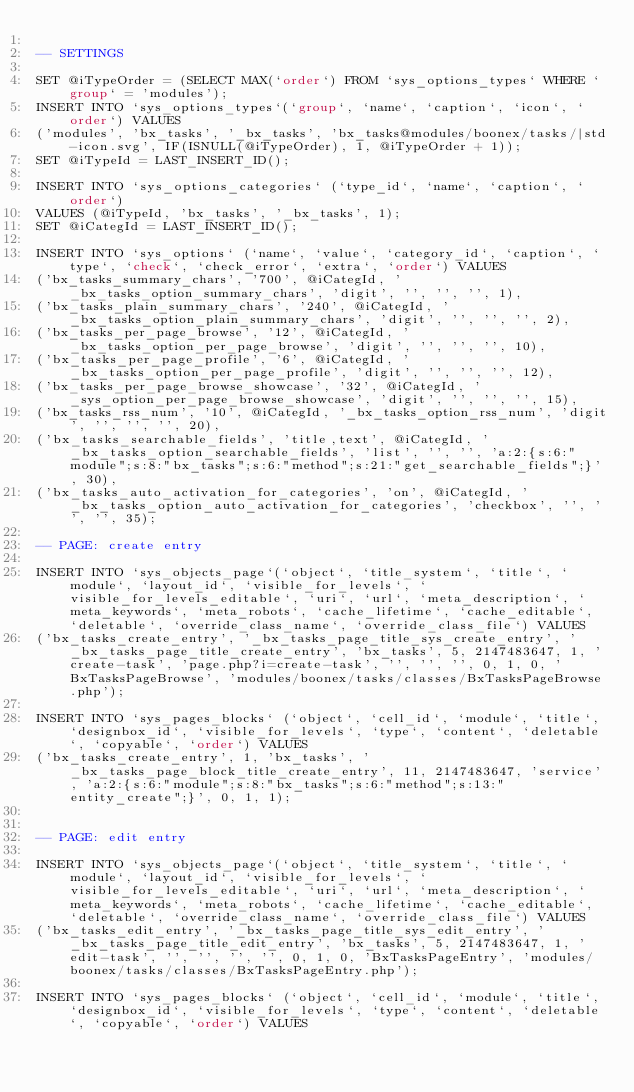Convert code to text. <code><loc_0><loc_0><loc_500><loc_500><_SQL_>
-- SETTINGS

SET @iTypeOrder = (SELECT MAX(`order`) FROM `sys_options_types` WHERE `group` = 'modules');
INSERT INTO `sys_options_types`(`group`, `name`, `caption`, `icon`, `order`) VALUES 
('modules', 'bx_tasks', '_bx_tasks', 'bx_tasks@modules/boonex/tasks/|std-icon.svg', IF(ISNULL(@iTypeOrder), 1, @iTypeOrder + 1));
SET @iTypeId = LAST_INSERT_ID();

INSERT INTO `sys_options_categories` (`type_id`, `name`, `caption`, `order`)
VALUES (@iTypeId, 'bx_tasks', '_bx_tasks', 1);
SET @iCategId = LAST_INSERT_ID();

INSERT INTO `sys_options` (`name`, `value`, `category_id`, `caption`, `type`, `check`, `check_error`, `extra`, `order`) VALUES
('bx_tasks_summary_chars', '700', @iCategId, '_bx_tasks_option_summary_chars', 'digit', '', '', '', 1),
('bx_tasks_plain_summary_chars', '240', @iCategId, '_bx_tasks_option_plain_summary_chars', 'digit', '', '', '', 2),
('bx_tasks_per_page_browse', '12', @iCategId, '_bx_tasks_option_per_page_browse', 'digit', '', '', '', 10),
('bx_tasks_per_page_profile', '6', @iCategId, '_bx_tasks_option_per_page_profile', 'digit', '', '', '', 12),
('bx_tasks_per_page_browse_showcase', '32', @iCategId, '_sys_option_per_page_browse_showcase', 'digit', '', '', '', 15),
('bx_tasks_rss_num', '10', @iCategId, '_bx_tasks_option_rss_num', 'digit', '', '', '', 20),
('bx_tasks_searchable_fields', 'title,text', @iCategId, '_bx_tasks_option_searchable_fields', 'list', '', '', 'a:2:{s:6:"module";s:8:"bx_tasks";s:6:"method";s:21:"get_searchable_fields";}', 30),
('bx_tasks_auto_activation_for_categories', 'on', @iCategId, '_bx_tasks_option_auto_activation_for_categories', 'checkbox', '', '', '', 35);

-- PAGE: create entry

INSERT INTO `sys_objects_page`(`object`, `title_system`, `title`, `module`, `layout_id`, `visible_for_levels`, `visible_for_levels_editable`, `uri`, `url`, `meta_description`, `meta_keywords`, `meta_robots`, `cache_lifetime`, `cache_editable`, `deletable`, `override_class_name`, `override_class_file`) VALUES 
('bx_tasks_create_entry', '_bx_tasks_page_title_sys_create_entry', '_bx_tasks_page_title_create_entry', 'bx_tasks', 5, 2147483647, 1, 'create-task', 'page.php?i=create-task', '', '', '', 0, 1, 0, 'BxTasksPageBrowse', 'modules/boonex/tasks/classes/BxTasksPageBrowse.php');

INSERT INTO `sys_pages_blocks` (`object`, `cell_id`, `module`, `title`, `designbox_id`, `visible_for_levels`, `type`, `content`, `deletable`, `copyable`, `order`) VALUES
('bx_tasks_create_entry', 1, 'bx_tasks', '_bx_tasks_page_block_title_create_entry', 11, 2147483647, 'service', 'a:2:{s:6:"module";s:8:"bx_tasks";s:6:"method";s:13:"entity_create";}', 0, 1, 1);


-- PAGE: edit entry

INSERT INTO `sys_objects_page`(`object`, `title_system`, `title`, `module`, `layout_id`, `visible_for_levels`, `visible_for_levels_editable`, `uri`, `url`, `meta_description`, `meta_keywords`, `meta_robots`, `cache_lifetime`, `cache_editable`, `deletable`, `override_class_name`, `override_class_file`) VALUES 
('bx_tasks_edit_entry', '_bx_tasks_page_title_sys_edit_entry', '_bx_tasks_page_title_edit_entry', 'bx_tasks', 5, 2147483647, 1, 'edit-task', '', '', '', '', 0, 1, 0, 'BxTasksPageEntry', 'modules/boonex/tasks/classes/BxTasksPageEntry.php');

INSERT INTO `sys_pages_blocks` (`object`, `cell_id`, `module`, `title`, `designbox_id`, `visible_for_levels`, `type`, `content`, `deletable`, `copyable`, `order`) VALUES</code> 